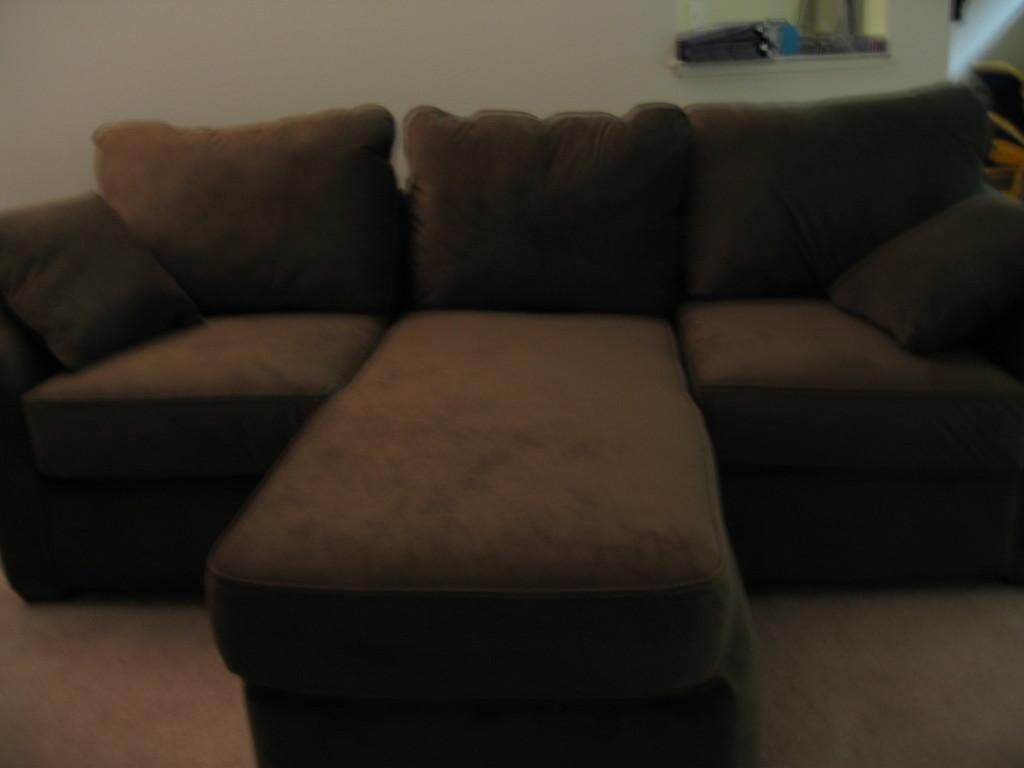What type of furniture is present in the image? There are sofas in the image. What can be seen on the wall in the image? There is a wall in the image. What type of fruit is hanging from the wall in the image? There is no fruit hanging from the wall in the image. What kind of quartz formation can be seen on the sofas in the image? There is no quartz formation present on the sofas in the image. 